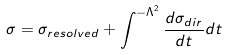<formula> <loc_0><loc_0><loc_500><loc_500>\sigma = \sigma _ { r e s o l v e d } + \int ^ { - \Lambda ^ { 2 } } \frac { d \sigma _ { d i r } } { d t } d t</formula> 